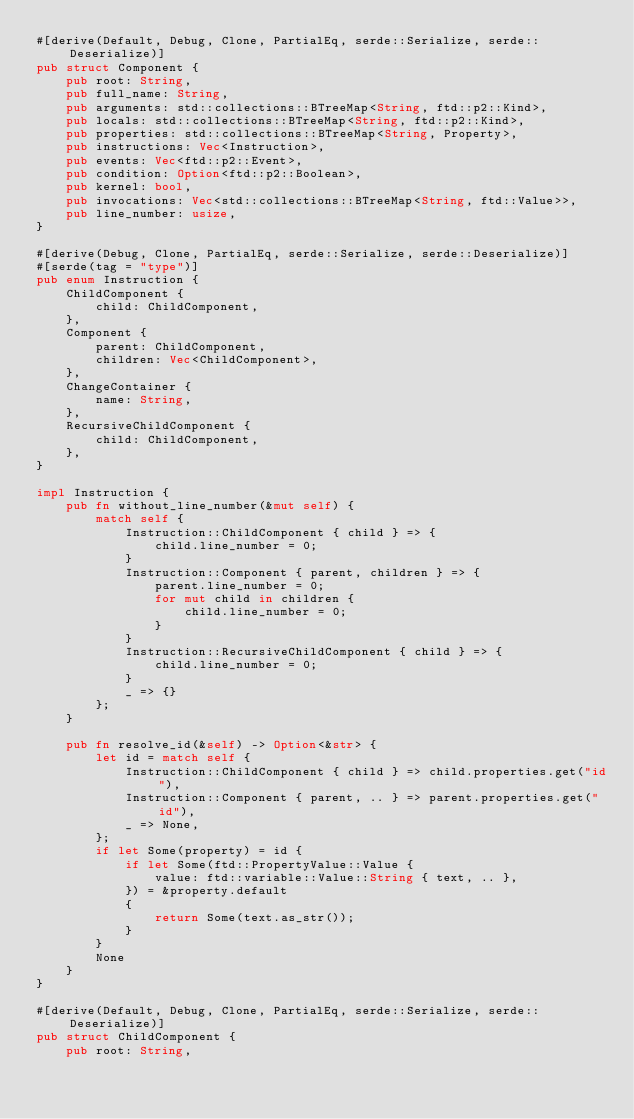Convert code to text. <code><loc_0><loc_0><loc_500><loc_500><_Rust_>#[derive(Default, Debug, Clone, PartialEq, serde::Serialize, serde::Deserialize)]
pub struct Component {
    pub root: String,
    pub full_name: String,
    pub arguments: std::collections::BTreeMap<String, ftd::p2::Kind>,
    pub locals: std::collections::BTreeMap<String, ftd::p2::Kind>,
    pub properties: std::collections::BTreeMap<String, Property>,
    pub instructions: Vec<Instruction>,
    pub events: Vec<ftd::p2::Event>,
    pub condition: Option<ftd::p2::Boolean>,
    pub kernel: bool,
    pub invocations: Vec<std::collections::BTreeMap<String, ftd::Value>>,
    pub line_number: usize,
}

#[derive(Debug, Clone, PartialEq, serde::Serialize, serde::Deserialize)]
#[serde(tag = "type")]
pub enum Instruction {
    ChildComponent {
        child: ChildComponent,
    },
    Component {
        parent: ChildComponent,
        children: Vec<ChildComponent>,
    },
    ChangeContainer {
        name: String,
    },
    RecursiveChildComponent {
        child: ChildComponent,
    },
}

impl Instruction {
    pub fn without_line_number(&mut self) {
        match self {
            Instruction::ChildComponent { child } => {
                child.line_number = 0;
            }
            Instruction::Component { parent, children } => {
                parent.line_number = 0;
                for mut child in children {
                    child.line_number = 0;
                }
            }
            Instruction::RecursiveChildComponent { child } => {
                child.line_number = 0;
            }
            _ => {}
        };
    }

    pub fn resolve_id(&self) -> Option<&str> {
        let id = match self {
            Instruction::ChildComponent { child } => child.properties.get("id"),
            Instruction::Component { parent, .. } => parent.properties.get("id"),
            _ => None,
        };
        if let Some(property) = id {
            if let Some(ftd::PropertyValue::Value {
                value: ftd::variable::Value::String { text, .. },
            }) = &property.default
            {
                return Some(text.as_str());
            }
        }
        None
    }
}

#[derive(Default, Debug, Clone, PartialEq, serde::Serialize, serde::Deserialize)]
pub struct ChildComponent {
    pub root: String,</code> 